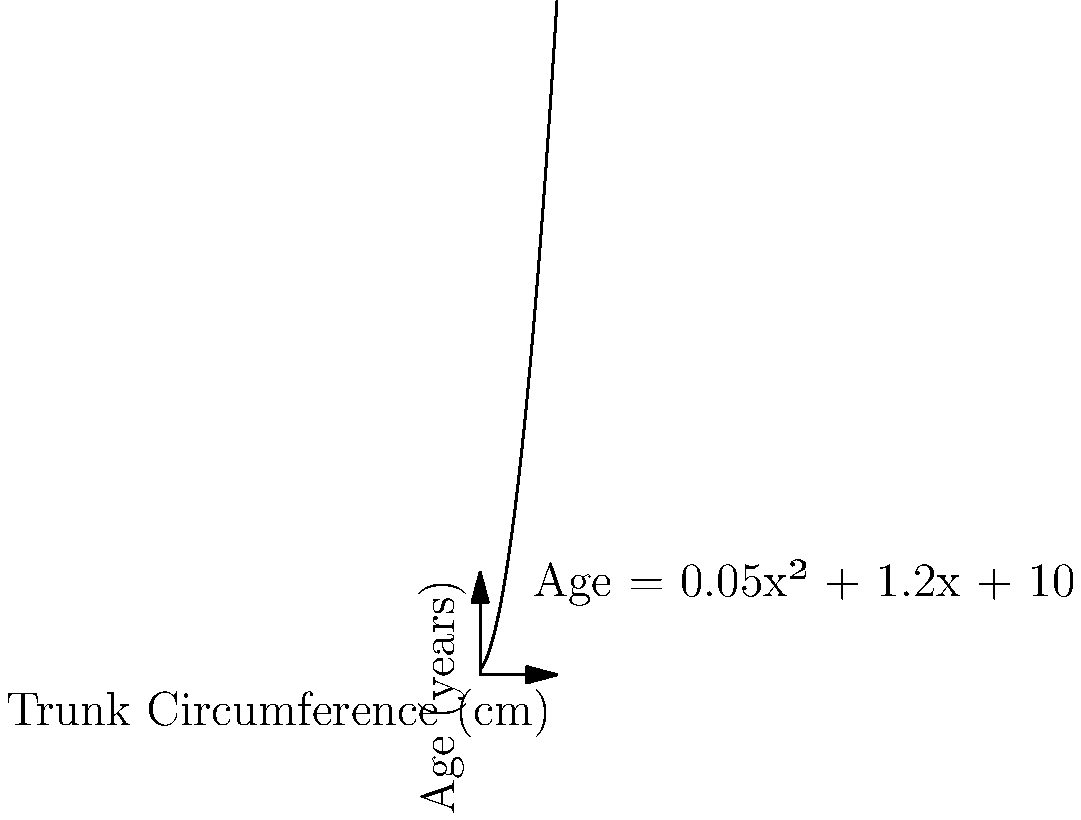Using the polynomial regression model shown in the graph, which relates a tree's age to its trunk circumference, estimate the age of a tree with a trunk circumference of 100 cm. Round your answer to the nearest year. To estimate the age of the tree, we need to use the polynomial equation given in the graph:

Age = 0.05x² + 1.2x + 10

where x is the trunk circumference in cm.

Let's solve this step-by-step:

1. Substitute x = 100 cm into the equation:
   Age = 0.05(100)² + 1.2(100) + 10

2. Calculate the squared term:
   Age = 0.05(10000) + 1.2(100) + 10

3. Multiply:
   Age = 500 + 120 + 10

4. Sum up the terms:
   Age = 630

5. Round to the nearest year:
   Age ≈ 630 years

Therefore, a tree with a trunk circumference of 100 cm is estimated to be approximately 630 years old according to this polynomial regression model.
Answer: 630 years 